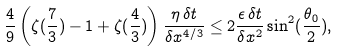Convert formula to latex. <formula><loc_0><loc_0><loc_500><loc_500>\frac { 4 } { 9 } \left ( \zeta ( \frac { 7 } { 3 } ) - 1 + \zeta ( \frac { 4 } { 3 } ) \right ) \frac { \eta \, \delta t } { \delta x ^ { 4 / 3 } } \leq 2 \frac { \epsilon \, \delta t } { \delta x ^ { 2 } } \sin ^ { 2 } ( \frac { \theta _ { 0 } } { 2 } ) ,</formula> 